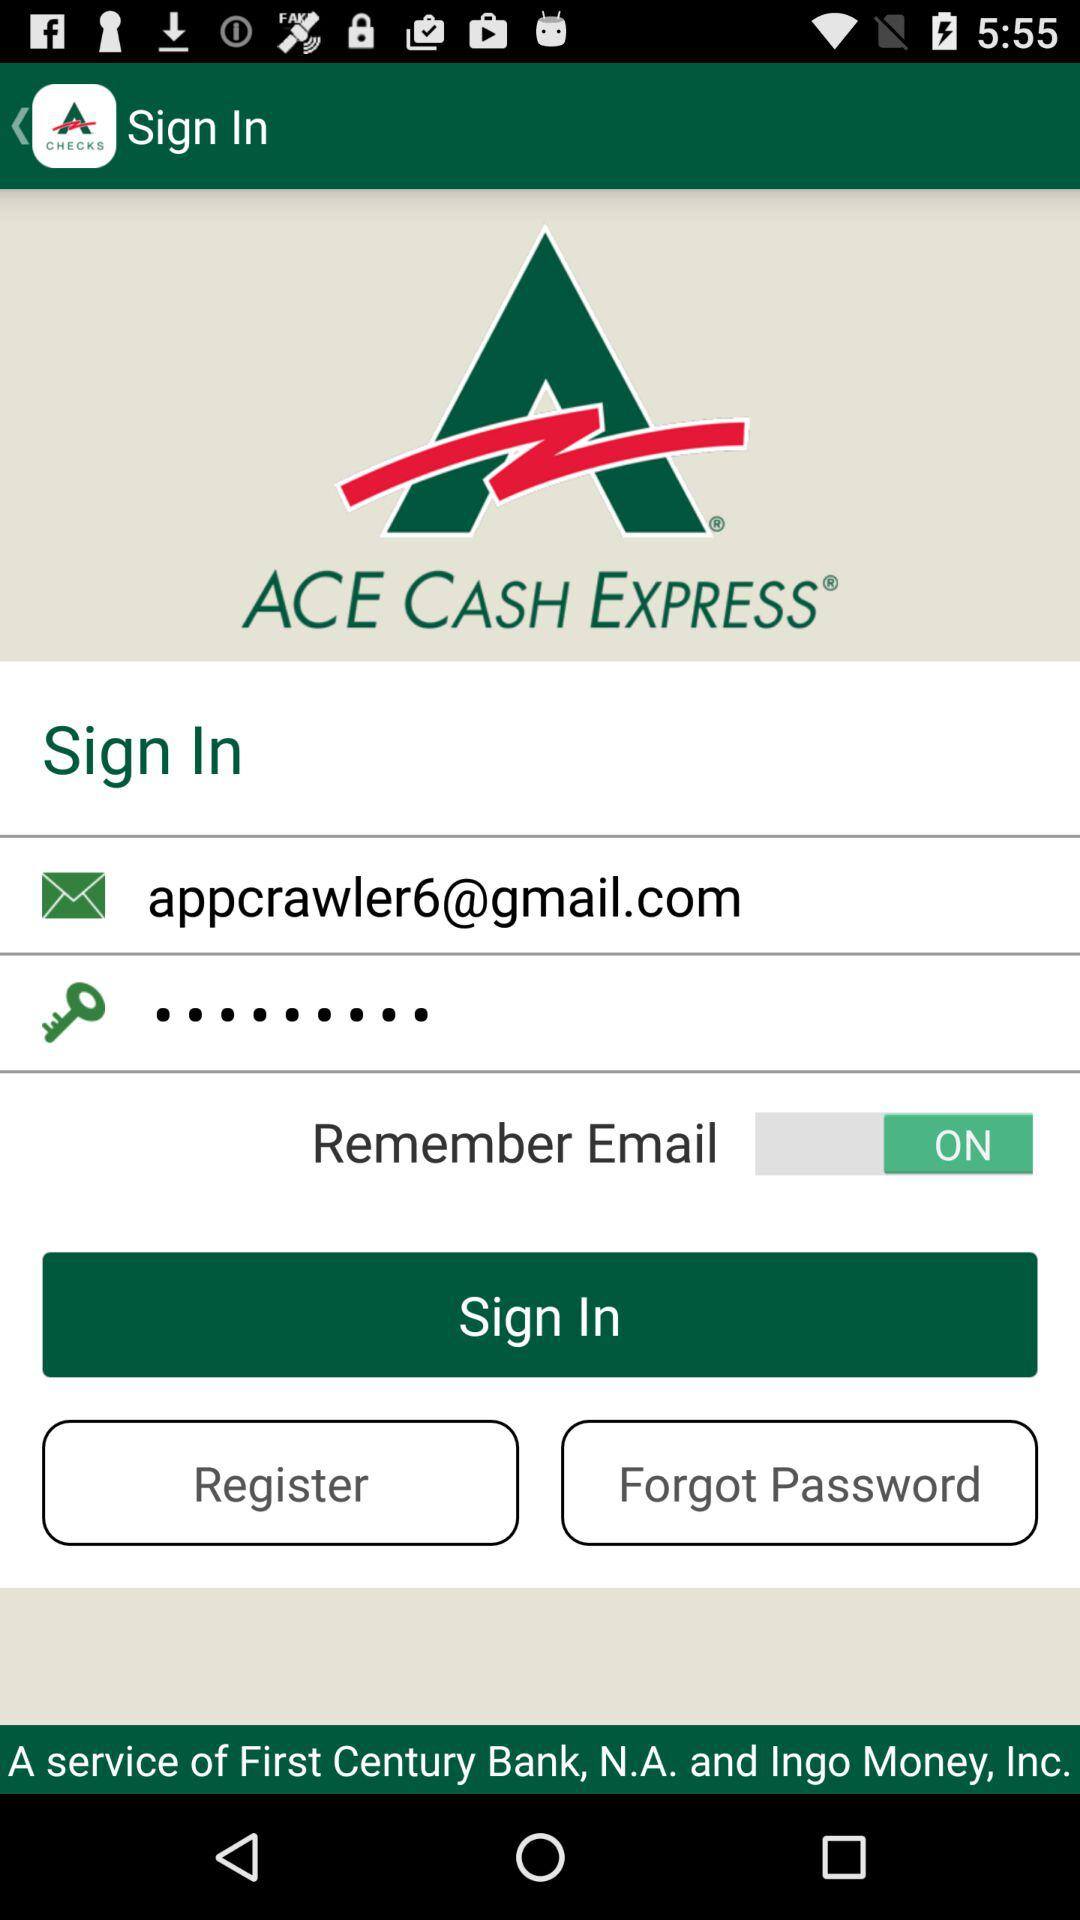What is the email address of the user? The email address is appcrawler6@gmail.com. 